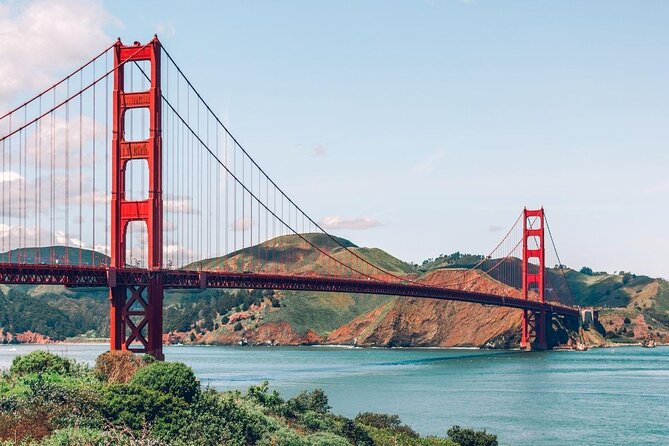Could you create a story where this bridge is the gateway to another world? In a world not so different from our own, the Golden Gate Bridge wasn't just a feat of engineering; it was a gateway to an alternate realm. Every seventh full moon, when the bridge cast its shadow just right, a portal would open at the base of its northern pillar. This hidden world, cloaked in magic and mystery, was called Aetheria. Aetheria was a land where mythical creatures roamed, and the laws of nature were poetically different. Its skies were painted with vibrant colors, and floating islands housed ancient, sentient beings that guarded secrets of the cosmos. Only the chosen few who dared to traverse the bridge at the sacred hour could glimpse this wonder. Legend has it that those who entered Aetheria would bring back tales of awe and marvel, forever changed by the magic they witnessed. The bridge, now more than just a marvel of human ambition, stood as a link between worlds, a timeless sentinel watching over both realms. 